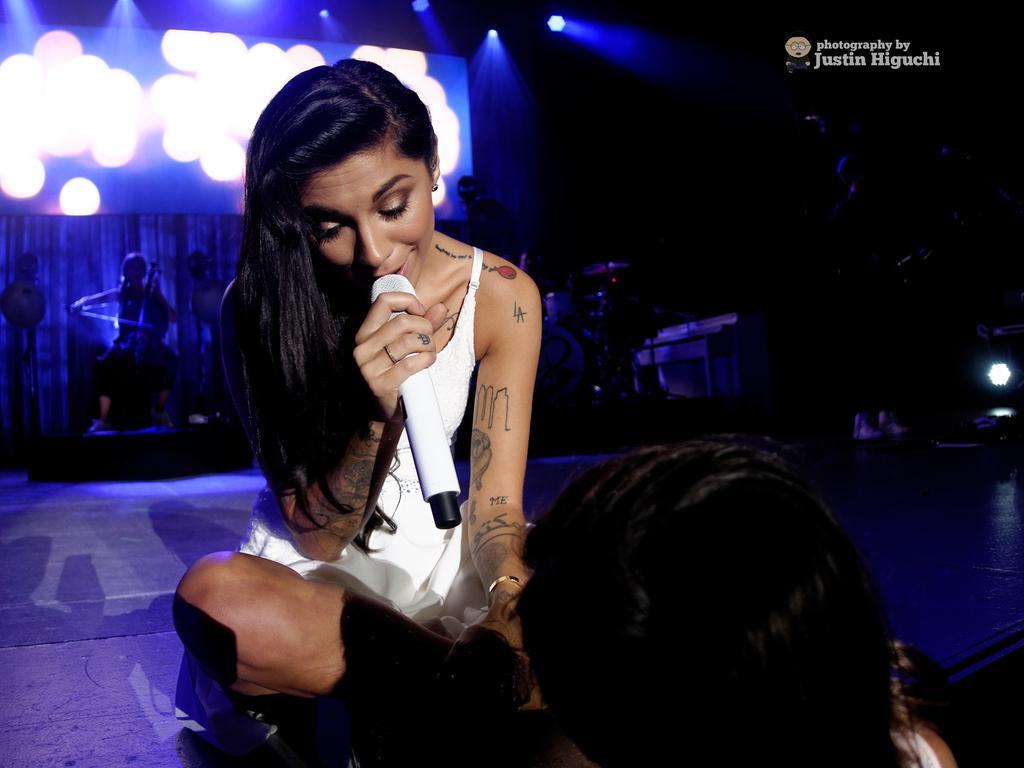Describe this image in one or two sentences. In the foreground of this image, there is a person´s head on the bottom and also a woman holding mic is sitting on the stage. In the dark background, there are lights, screen, a woman playing violin and seems like a curtain in the background. 